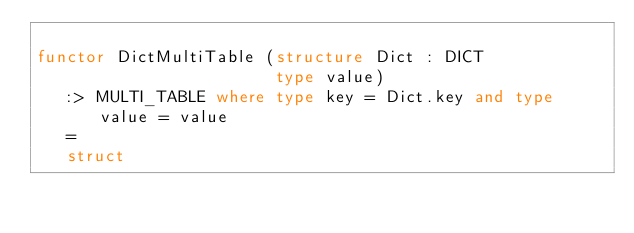Convert code to text. <code><loc_0><loc_0><loc_500><loc_500><_SML_>
functor DictMultiTable (structure Dict : DICT
                        type value)
   :> MULTI_TABLE where type key = Dict.key and type value = value
   = 
   struct
</code> 